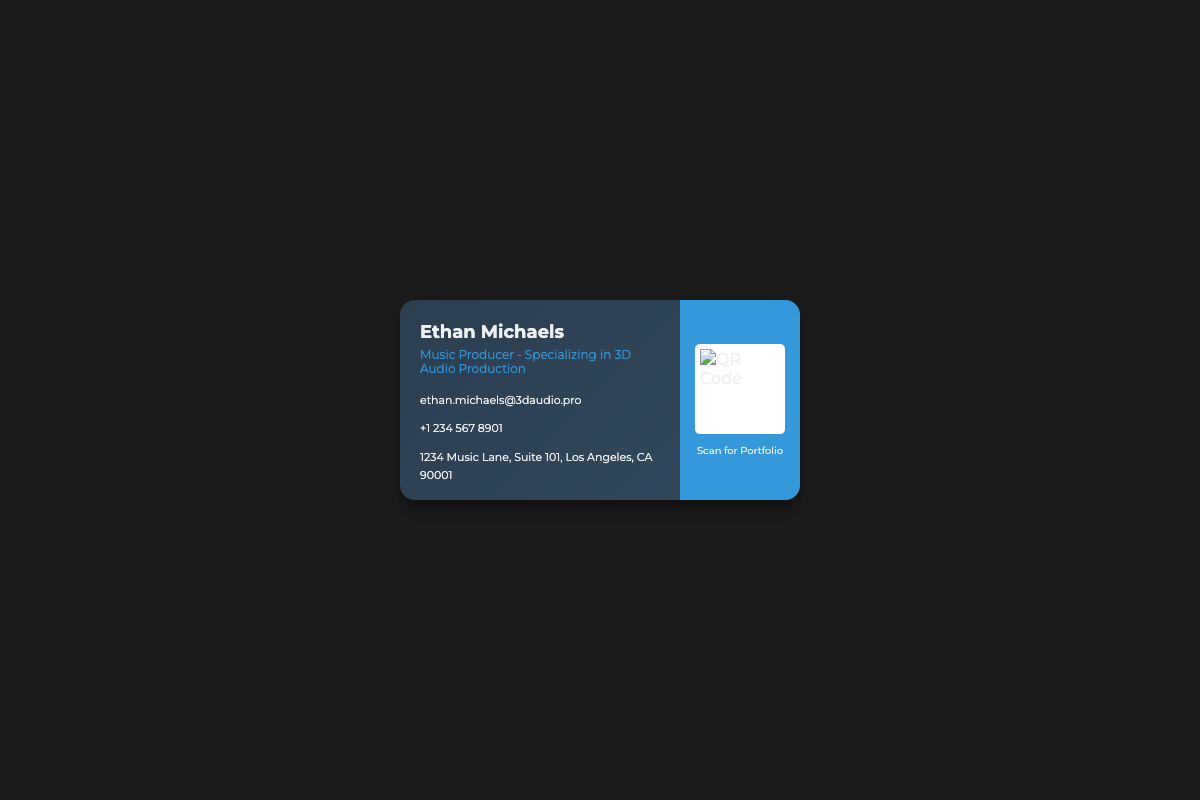What is Ethan Michaels' specialization? The document states that Ethan Michaels specializes in 3D Audio Production.
Answer: 3D Audio Production What is Ethan Michaels' email address? The email address provided in the document is ethan.michaels@3daudio.pro.
Answer: ethan.michaels@3daudio.pro What city is Ethan Michaels located in? The address on the card lists Los Angeles as the city.
Answer: Los Angeles What is the phone number listed on the business card? The business card features the phone number +1 234 567 8901.
Answer: +1 234 567 8901 How many social media links are mentioned on the card? There are three social media links provided on the card.
Answer: 3 What does the QR Code link to? The QR Code is labeled to scan for Ethan Michaels' portfolio.
Answer: Portfolio What is the color scheme of the business card? The color scheme includes a gradient of dark blue and gray tones.
Answer: Dark blue and gray What is the purpose of the social media icons on the card? The social media icons allow users to connect with Ethan Michaels on various platforms.
Answer: Connect on social media What is the design style of the card? The card features a modern and sleek design with gradient colors and rounded corners.
Answer: Modern design 